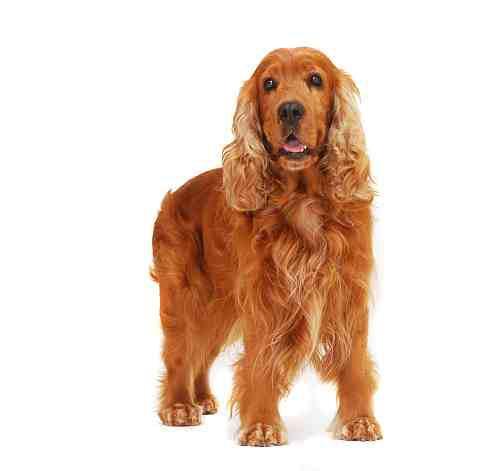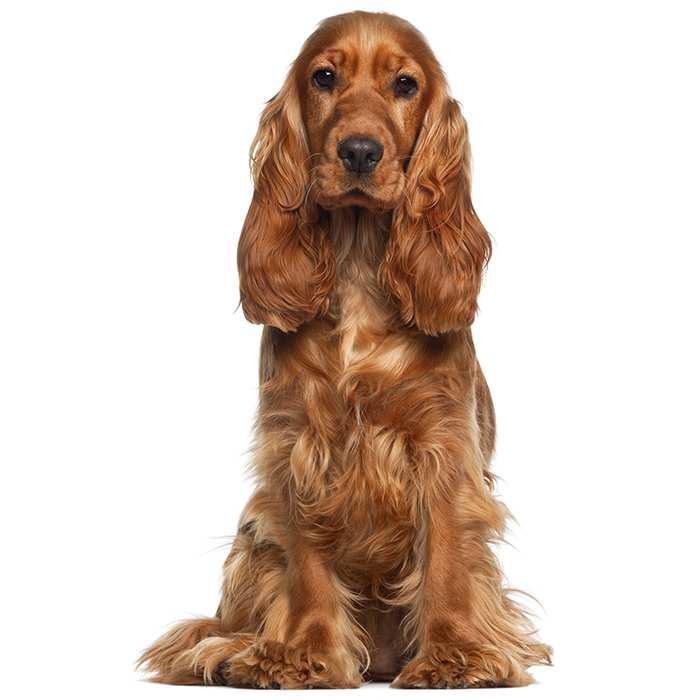The first image is the image on the left, the second image is the image on the right. Analyze the images presented: Is the assertion "One image has a colored background, while the other is white, they are not the same." valid? Answer yes or no. No. 